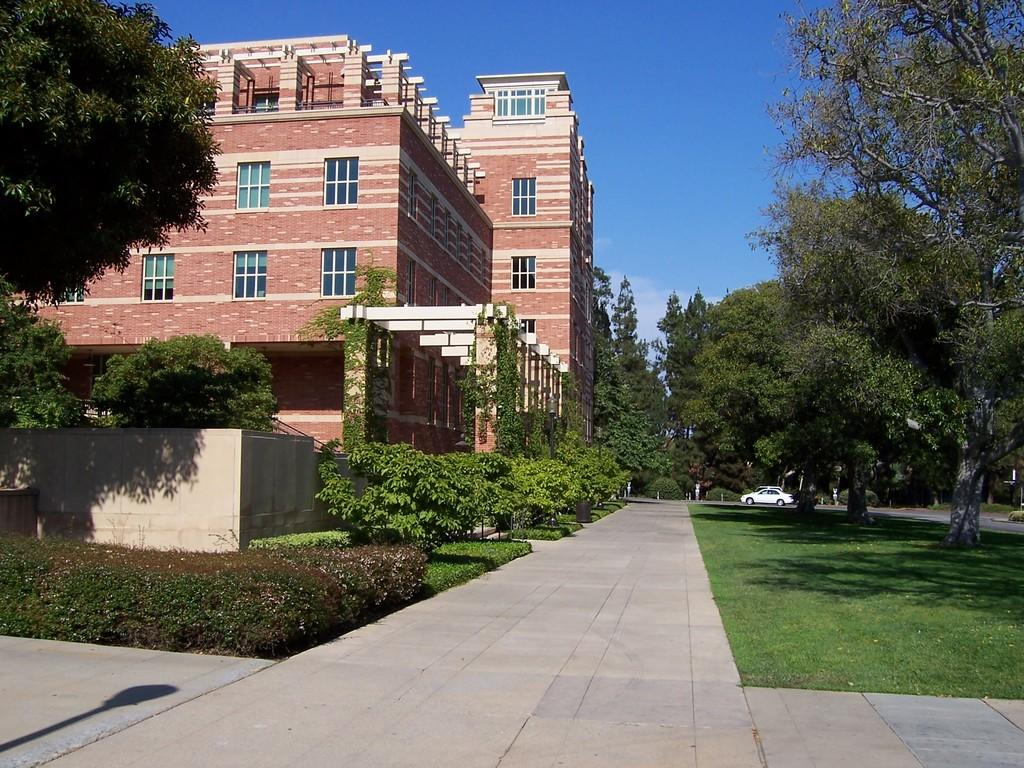What type of structures can be seen in the image? There are buildings in the image. What natural elements are present in the image? There are trees, plants, and grass in the image. What part of the natural environment is visible in the image? The sky is visible in the image. Can you describe any vehicles in the image? There is a white color car in the background of the image. What type of vest is the tree wearing in the image? There are no vests present in the image, as trees are not capable of wearing clothing. What sense is being stimulated by the linen in the image? There is no linen present in the image, so it is not possible to determine which sense might be stimulated. 